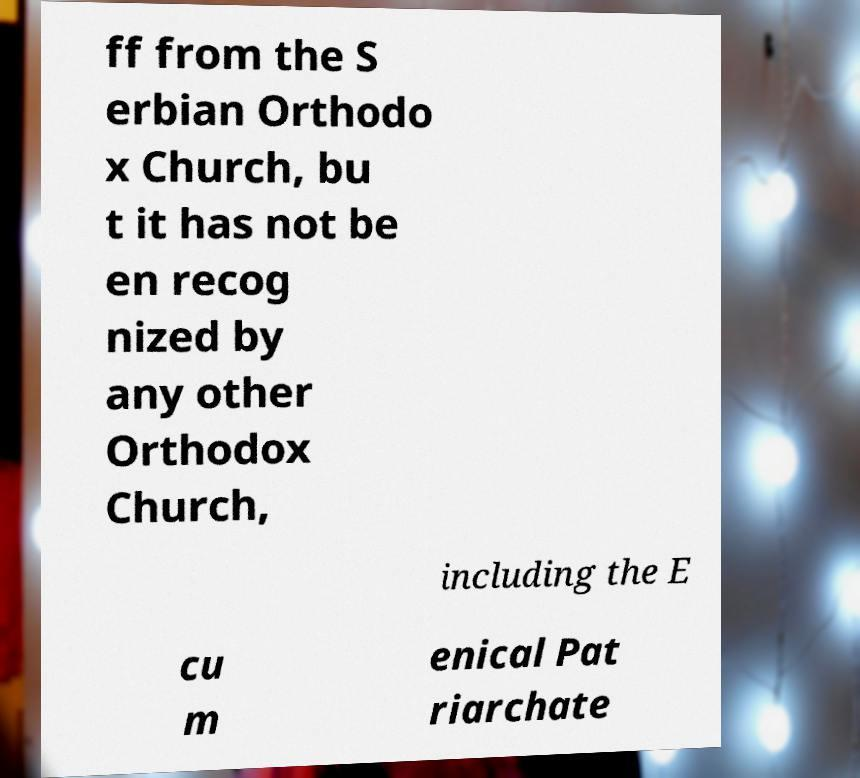I need the written content from this picture converted into text. Can you do that? ff from the S erbian Orthodo x Church, bu t it has not be en recog nized by any other Orthodox Church, including the E cu m enical Pat riarchate 